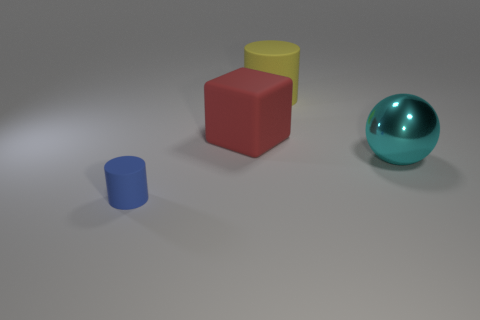Imagine these objects are part of a larger scene. What sort of setting might they be in? If these objects were part of a larger scene, they might be situated in a modern home as decorative items on a shelf, or perhaps they are part of a child's simple playset with basic geometric shapes for educational purposes. 